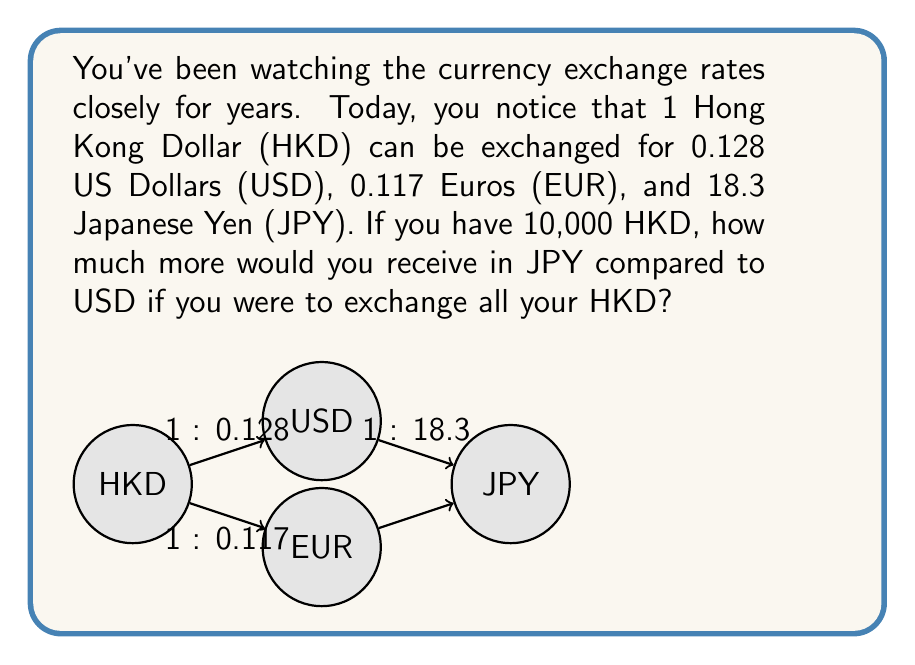Provide a solution to this math problem. Let's approach this step-by-step:

1) First, let's calculate how much USD you would receive for 10,000 HKD:
   $$10,000 \text{ HKD} \times 0.128 \text{ USD/HKD} = 1,280 \text{ USD}$$

2) Now, let's calculate how much JPY you would receive for 10,000 HKD:
   $$10,000 \text{ HKD} \times 18.3 \text{ JPY/HKD} = 183,000 \text{ JPY}$$

3) To compare these amounts, we need to convert the USD amount to JPY. We can do this using the cross-rate between USD and JPY:
   $$\text{JPY/USD} = \frac{\text{JPY/HKD}}{\text{USD/HKD}} = \frac{18.3}{0.128} = 142.96875$$

4) Now we can convert 1,280 USD to JPY:
   $$1,280 \text{ USD} \times 142.96875 \text{ JPY/USD} = 183,000 \text{ JPY}$$

5) The difference between the JPY amounts is:
   $$183,000 \text{ JPY} - 183,000 \text{ JPY} = 0 \text{ JPY}$$

Therefore, you would receive the same amount in JPY whether you exchange directly from HKD to JPY or go through USD first.
Answer: 0 JPY 